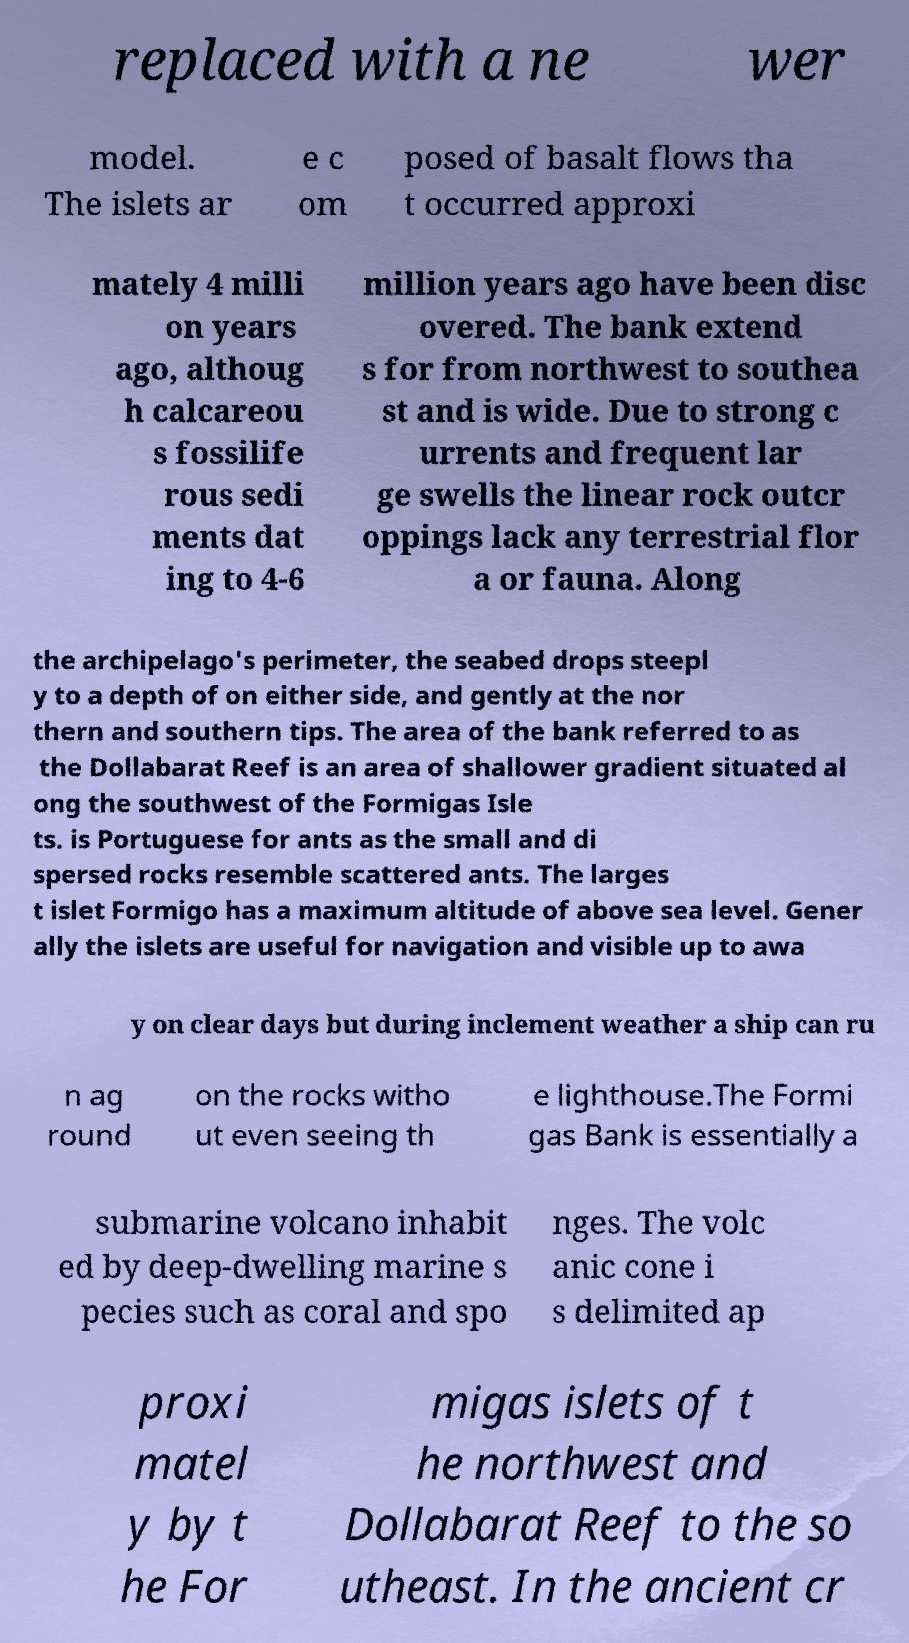Can you read and provide the text displayed in the image?This photo seems to have some interesting text. Can you extract and type it out for me? replaced with a ne wer model. The islets ar e c om posed of basalt flows tha t occurred approxi mately 4 milli on years ago, althoug h calcareou s fossilife rous sedi ments dat ing to 4-6 million years ago have been disc overed. The bank extend s for from northwest to southea st and is wide. Due to strong c urrents and frequent lar ge swells the linear rock outcr oppings lack any terrestrial flor a or fauna. Along the archipelago's perimeter, the seabed drops steepl y to a depth of on either side, and gently at the nor thern and southern tips. The area of the bank referred to as the Dollabarat Reef is an area of shallower gradient situated al ong the southwest of the Formigas Isle ts. is Portuguese for ants as the small and di spersed rocks resemble scattered ants. The larges t islet Formigo has a maximum altitude of above sea level. Gener ally the islets are useful for navigation and visible up to awa y on clear days but during inclement weather a ship can ru n ag round on the rocks witho ut even seeing th e lighthouse.The Formi gas Bank is essentially a submarine volcano inhabit ed by deep-dwelling marine s pecies such as coral and spo nges. The volc anic cone i s delimited ap proxi matel y by t he For migas islets of t he northwest and Dollabarat Reef to the so utheast. In the ancient cr 